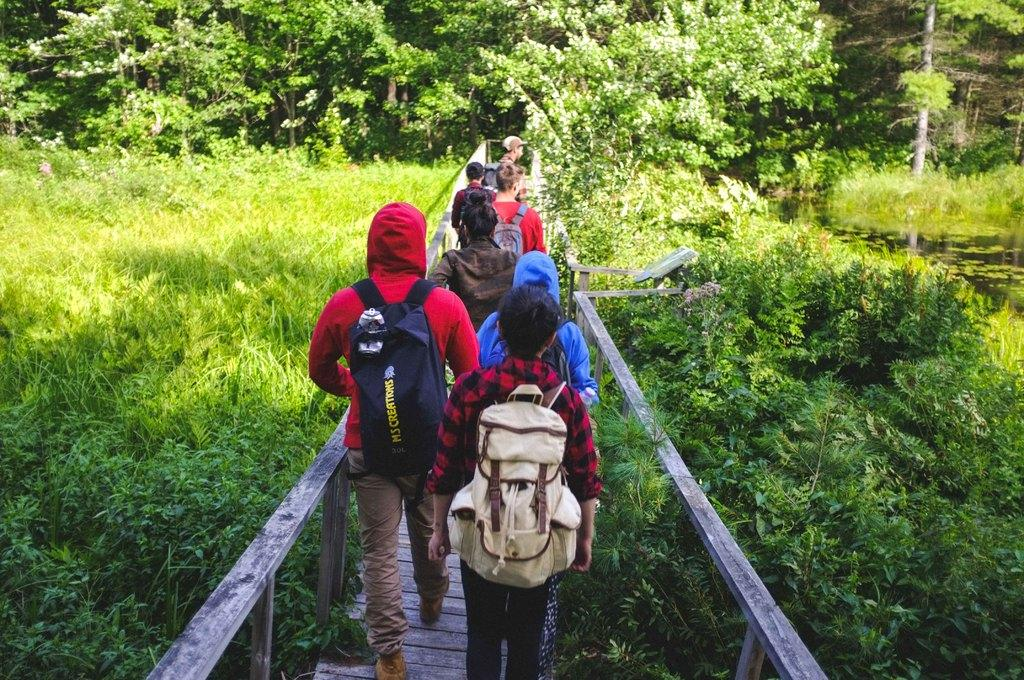How many people are in the image? There are persons in the image, but the exact number is not specified. What are the persons wearing in the image? The persons are wearing bags in the image. What type of vegetation can be seen in the image? There are plants in the image. What can be seen in the background of the image? There are trees in the background of the image. What type of advertisement can be seen on the trees in the image? There is no advertisement present on the trees in the image. What type of play are the persons participating in while wearing bags? There is no indication of a play or any specific activity involving the persons wearing bags in the image. 